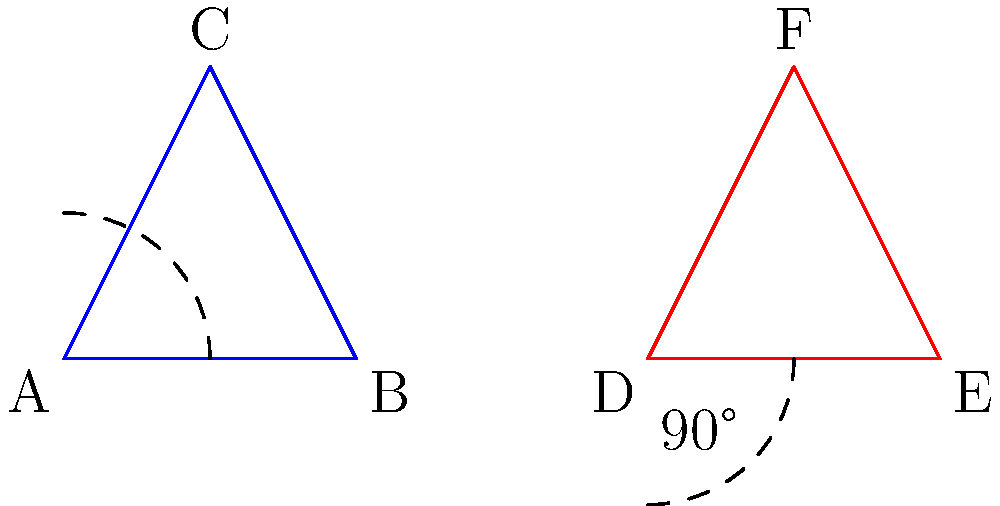A soccer team's formation is represented by triangle ABC. The coach wants to explore a mirrored strategy by rotating the formation 90° clockwise. If the new formation is represented by triangle DEF, what transformation would correctly describe the relationship between ABC and DEF? To solve this problem, let's analyze the transformation step-by-step:

1. Observe the original triangle ABC (blue) and the transformed triangle DEF (red).

2. Notice that triangle DEF appears to be a mirror image of ABC, but rotated.

3. The question states that the transformation involves a 90° clockwise rotation.

4. In transformational geometry, a 90° clockwise rotation is equivalent to a rotation of -90° (counterclockwise) around the origin.

5. However, simply rotating ABC by -90° would not produce DEF. There's an additional transformation involved.

6. The key is to recognize that DEF is a mirror image of ABC after the rotation.

7. In transformational geometry, a mirror image is created through reflection.

8. The correct sequence of transformations is:
   a) Reflect triangle ABC over the y-axis
   b) Rotate the resulting triangle -90° around the origin

9. This combination of reflection and rotation is known as a glide reflection.

10. In this case, the glide reflection involves a reflection over the y-axis followed by a -90° rotation.
Answer: Glide reflection (reflection over y-axis, then -90° rotation) 